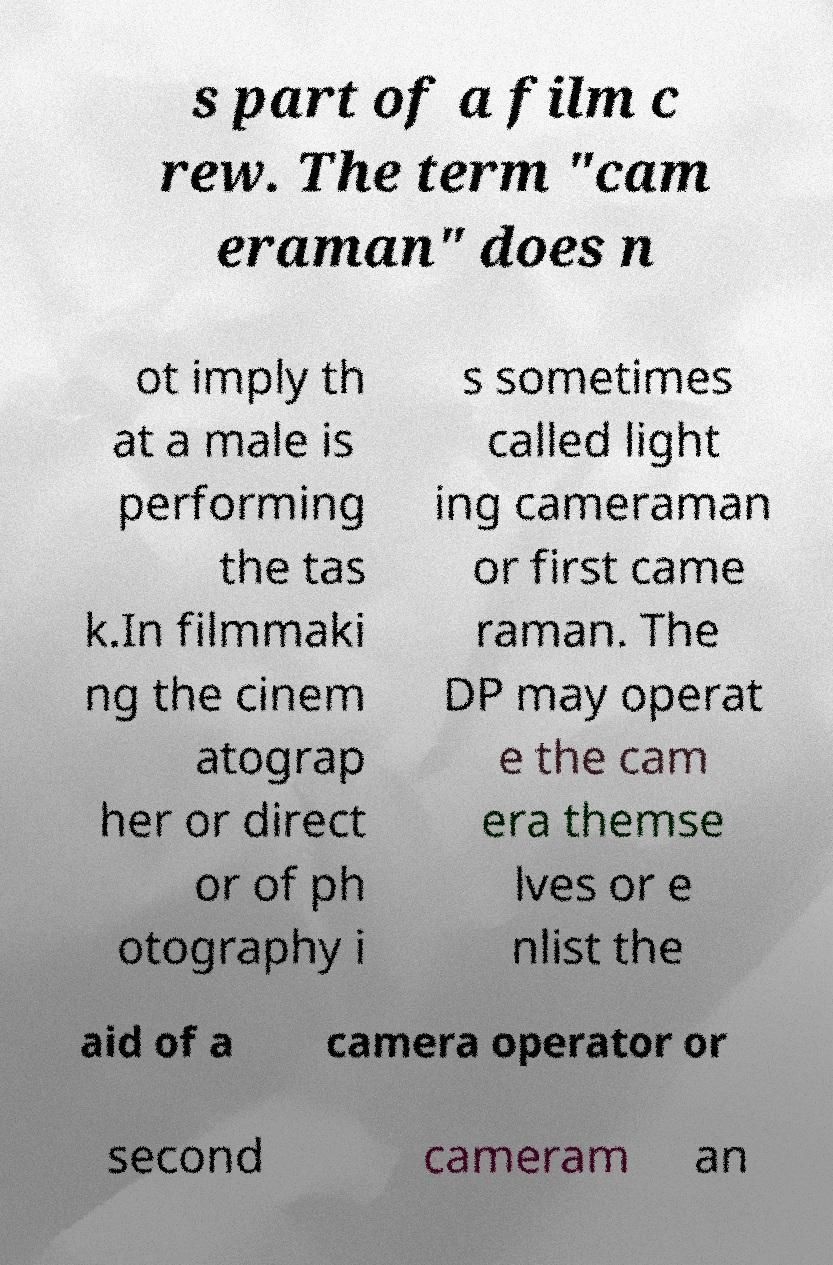Please identify and transcribe the text found in this image. s part of a film c rew. The term "cam eraman" does n ot imply th at a male is performing the tas k.In filmmaki ng the cinem atograp her or direct or of ph otography i s sometimes called light ing cameraman or first came raman. The DP may operat e the cam era themse lves or e nlist the aid of a camera operator or second cameram an 